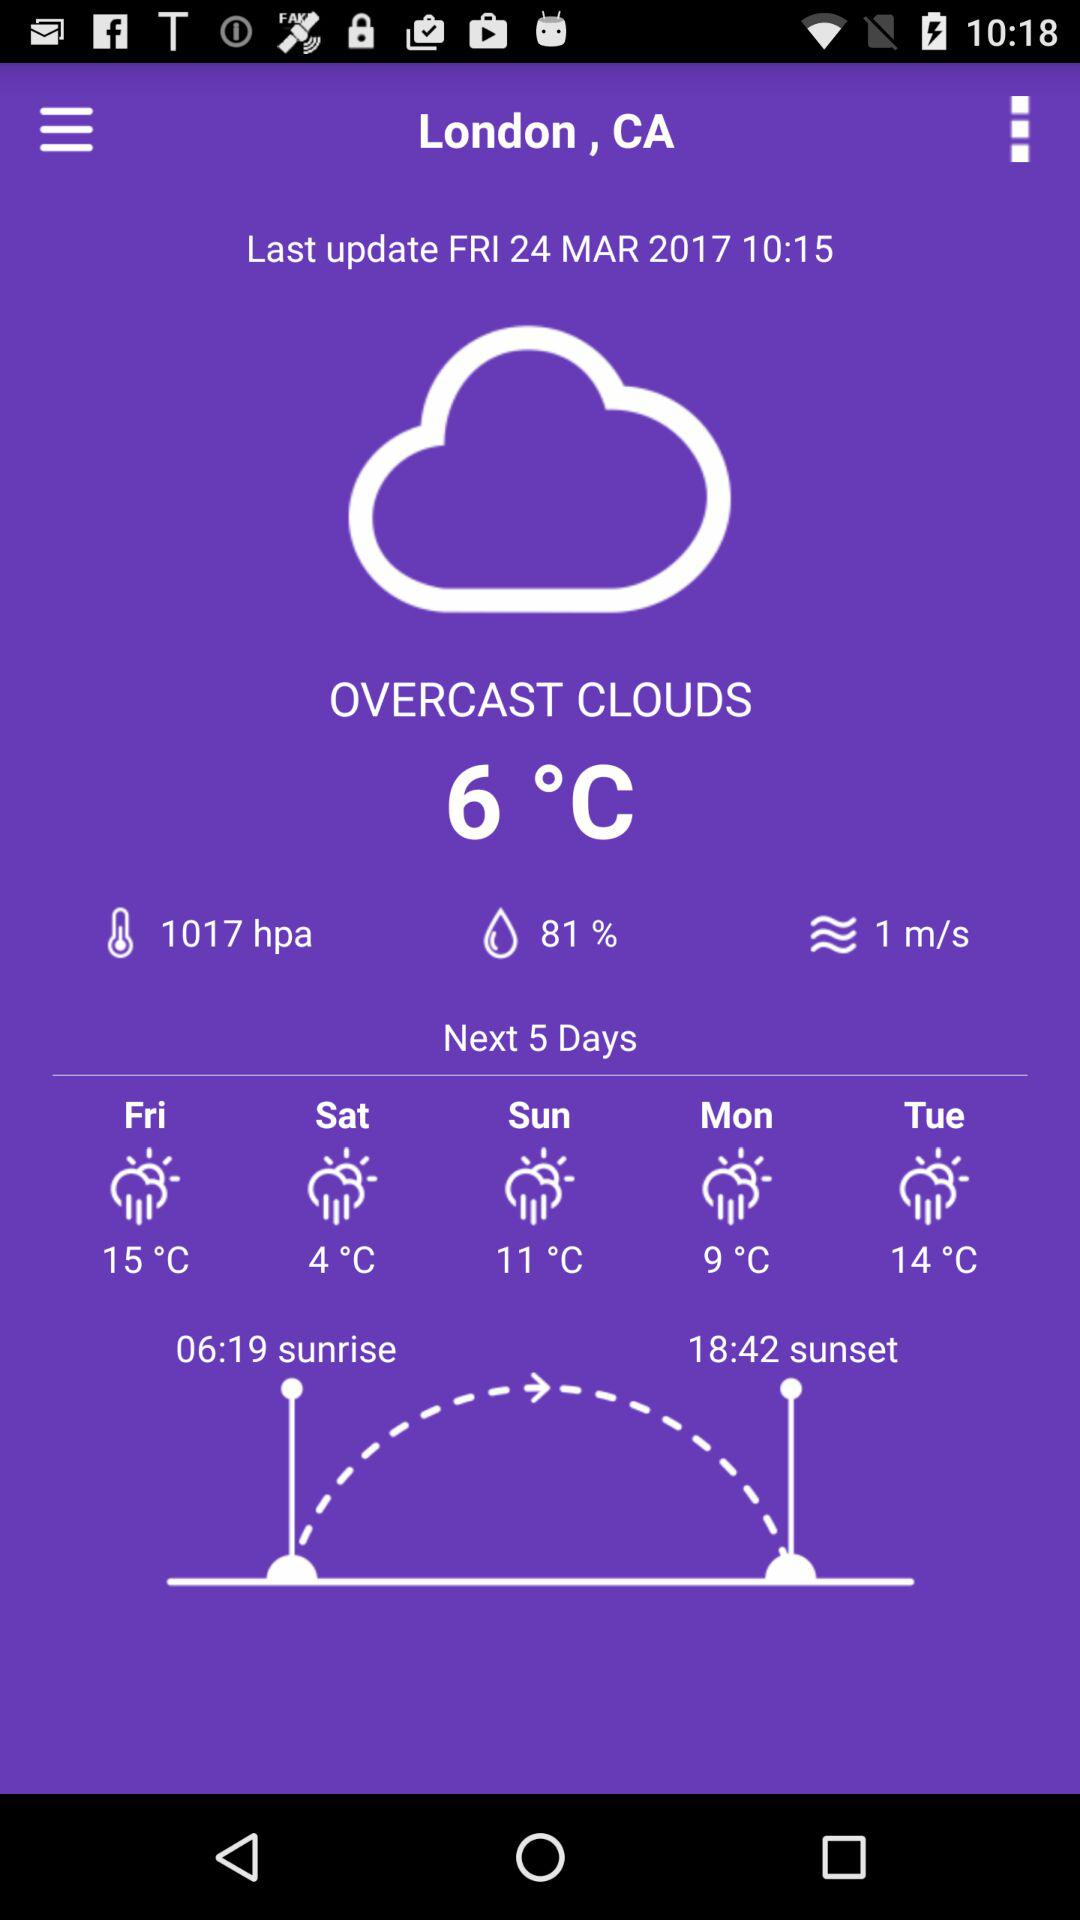What is the last updated date? The last updated date is Friday, March 24, 2017. 